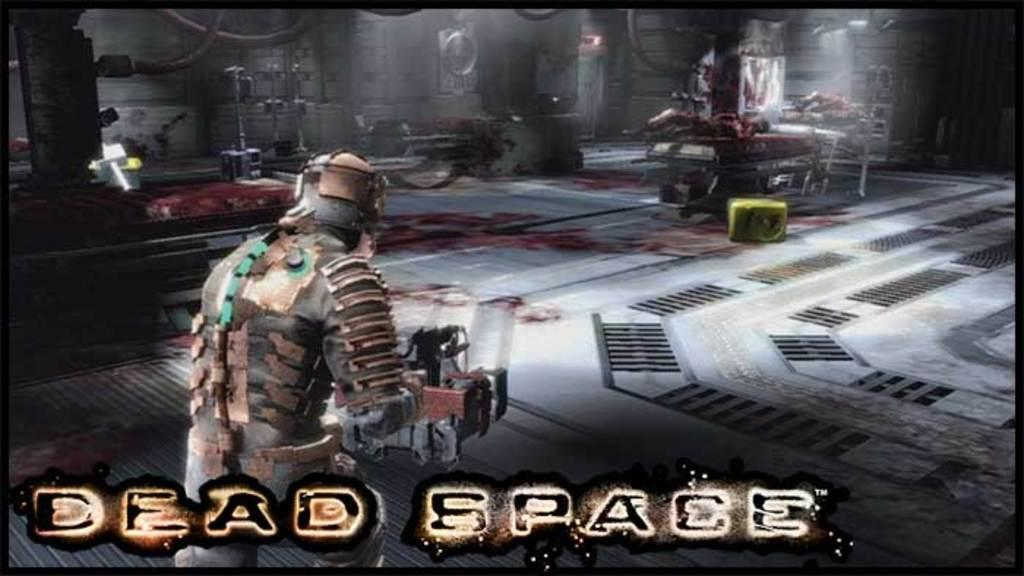What type of image is being shown? The image is a screen from a game. What is the man in the image holding? The man in the image is holding a weapon in his hand. What type of furniture can be seen in the image? There are beds in the image. What other objects are present in the image? There are machineries in the image. How many bells are hanging from the machineries in the image? There are no bells present in the image; it only features a man with a weapon, beds, and machineries. 